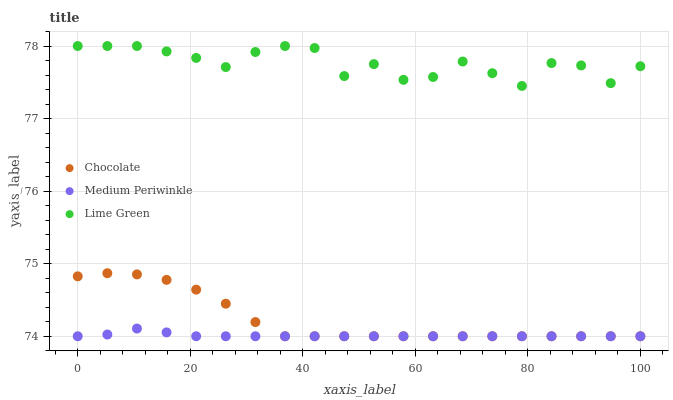Does Medium Periwinkle have the minimum area under the curve?
Answer yes or no. Yes. Does Lime Green have the maximum area under the curve?
Answer yes or no. Yes. Does Chocolate have the minimum area under the curve?
Answer yes or no. No. Does Chocolate have the maximum area under the curve?
Answer yes or no. No. Is Medium Periwinkle the smoothest?
Answer yes or no. Yes. Is Lime Green the roughest?
Answer yes or no. Yes. Is Chocolate the smoothest?
Answer yes or no. No. Is Chocolate the roughest?
Answer yes or no. No. Does Medium Periwinkle have the lowest value?
Answer yes or no. Yes. Does Lime Green have the highest value?
Answer yes or no. Yes. Does Chocolate have the highest value?
Answer yes or no. No. Is Medium Periwinkle less than Lime Green?
Answer yes or no. Yes. Is Lime Green greater than Chocolate?
Answer yes or no. Yes. Does Medium Periwinkle intersect Chocolate?
Answer yes or no. Yes. Is Medium Periwinkle less than Chocolate?
Answer yes or no. No. Is Medium Periwinkle greater than Chocolate?
Answer yes or no. No. Does Medium Periwinkle intersect Lime Green?
Answer yes or no. No. 